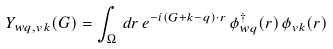<formula> <loc_0><loc_0><loc_500><loc_500>Y _ { w q , v k } ( G ) = \int _ { \Omega } \, d r \, e ^ { - i ( G + k - q ) \cdot r } \, \phi ^ { \dag } _ { w q } ( r ) \, \phi _ { v k } ( r )</formula> 